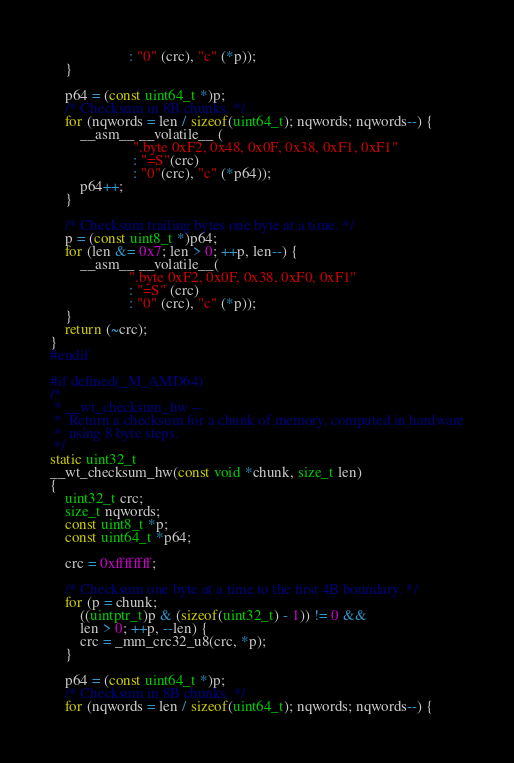<code> <loc_0><loc_0><loc_500><loc_500><_C_>				     : "0" (crc), "c" (*p));
	}

	p64 = (const uint64_t *)p;
	/* Checksum in 8B chunks. */
	for (nqwords = len / sizeof(uint64_t); nqwords; nqwords--) {
		__asm__ __volatile__ (
				      ".byte 0xF2, 0x48, 0x0F, 0x38, 0xF1, 0xF1"
				      : "=S"(crc)
				      : "0"(crc), "c" (*p64));
		p64++;
	}

	/* Checksum trailing bytes one byte at a time. */
	p = (const uint8_t *)p64;
	for (len &= 0x7; len > 0; ++p, len--) {
		__asm__ __volatile__(
				     ".byte 0xF2, 0x0F, 0x38, 0xF0, 0xF1"
				     : "=S" (crc)
				     : "0" (crc), "c" (*p));
	}
	return (~crc);
}
#endif

#if defined(_M_AMD64)
/*
 * __wt_checksum_hw --
 *	Return a checksum for a chunk of memory, computed in hardware
 *	using 8 byte steps.
 */
static uint32_t
__wt_checksum_hw(const void *chunk, size_t len)
{
	uint32_t crc;
	size_t nqwords;
	const uint8_t *p;
	const uint64_t *p64;

	crc = 0xffffffff;

	/* Checksum one byte at a time to the first 4B boundary. */
	for (p = chunk;
	    ((uintptr_t)p & (sizeof(uint32_t) - 1)) != 0 &&
	    len > 0; ++p, --len) {
		crc = _mm_crc32_u8(crc, *p);
	}

	p64 = (const uint64_t *)p;
	/* Checksum in 8B chunks. */
	for (nqwords = len / sizeof(uint64_t); nqwords; nqwords--) {</code> 